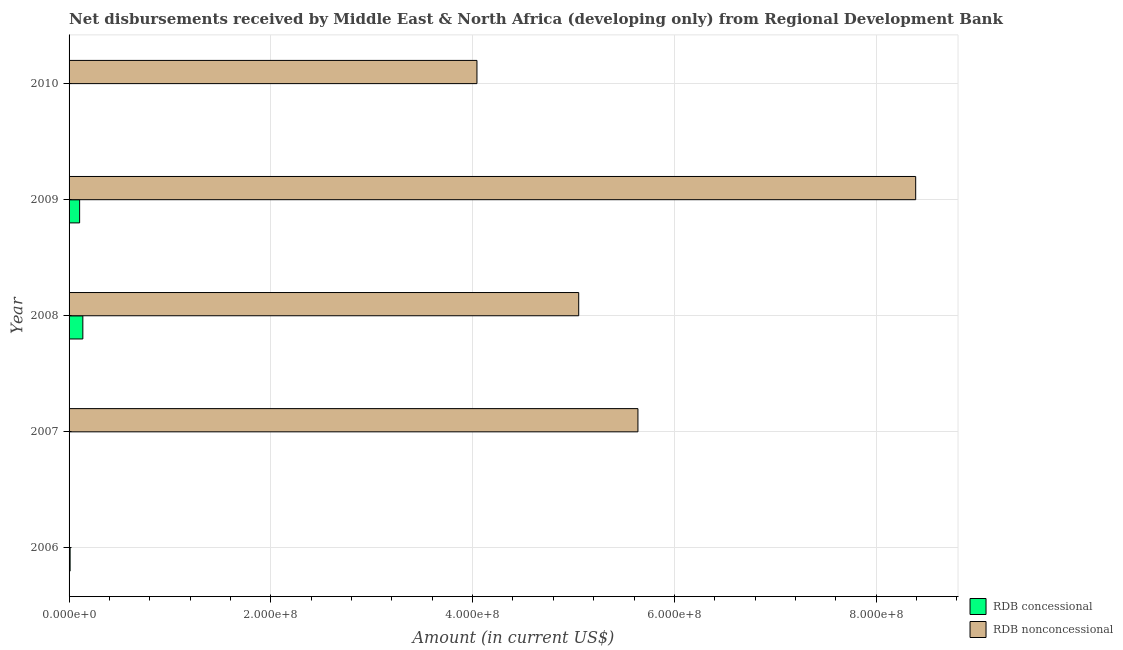Are the number of bars per tick equal to the number of legend labels?
Your answer should be very brief. No. Are the number of bars on each tick of the Y-axis equal?
Keep it short and to the point. No. How many bars are there on the 1st tick from the top?
Keep it short and to the point. 1. How many bars are there on the 1st tick from the bottom?
Ensure brevity in your answer.  1. What is the net non concessional disbursements from rdb in 2006?
Provide a succinct answer. 0. Across all years, what is the maximum net non concessional disbursements from rdb?
Provide a succinct answer. 8.39e+08. What is the total net concessional disbursements from rdb in the graph?
Keep it short and to the point. 2.54e+07. What is the difference between the net non concessional disbursements from rdb in 2008 and that in 2009?
Offer a terse response. -3.34e+08. What is the difference between the net non concessional disbursements from rdb in 2007 and the net concessional disbursements from rdb in 2010?
Provide a succinct answer. 5.64e+08. What is the average net concessional disbursements from rdb per year?
Provide a short and direct response. 5.08e+06. In the year 2008, what is the difference between the net concessional disbursements from rdb and net non concessional disbursements from rdb?
Your response must be concise. -4.92e+08. In how many years, is the net concessional disbursements from rdb greater than 760000000 US$?
Keep it short and to the point. 0. What is the ratio of the net concessional disbursements from rdb in 2008 to that in 2009?
Provide a succinct answer. 1.3. Is the net concessional disbursements from rdb in 2007 less than that in 2009?
Keep it short and to the point. Yes. Is the difference between the net non concessional disbursements from rdb in 2008 and 2009 greater than the difference between the net concessional disbursements from rdb in 2008 and 2009?
Your answer should be very brief. No. What is the difference between the highest and the second highest net non concessional disbursements from rdb?
Keep it short and to the point. 2.75e+08. What is the difference between the highest and the lowest net concessional disbursements from rdb?
Your answer should be very brief. 1.36e+07. In how many years, is the net non concessional disbursements from rdb greater than the average net non concessional disbursements from rdb taken over all years?
Provide a short and direct response. 3. Is the sum of the net non concessional disbursements from rdb in 2008 and 2009 greater than the maximum net concessional disbursements from rdb across all years?
Give a very brief answer. Yes. How many bars are there?
Provide a succinct answer. 8. Are the values on the major ticks of X-axis written in scientific E-notation?
Give a very brief answer. Yes. Does the graph contain any zero values?
Offer a terse response. Yes. Does the graph contain grids?
Ensure brevity in your answer.  Yes. How many legend labels are there?
Keep it short and to the point. 2. What is the title of the graph?
Your answer should be very brief. Net disbursements received by Middle East & North Africa (developing only) from Regional Development Bank. What is the label or title of the X-axis?
Provide a short and direct response. Amount (in current US$). What is the label or title of the Y-axis?
Keep it short and to the point. Year. What is the Amount (in current US$) in RDB concessional in 2006?
Your answer should be compact. 1.03e+06. What is the Amount (in current US$) in RDB concessional in 2007?
Provide a succinct answer. 2.37e+05. What is the Amount (in current US$) in RDB nonconcessional in 2007?
Your answer should be compact. 5.64e+08. What is the Amount (in current US$) of RDB concessional in 2008?
Provide a succinct answer. 1.36e+07. What is the Amount (in current US$) of RDB nonconcessional in 2008?
Provide a short and direct response. 5.05e+08. What is the Amount (in current US$) of RDB concessional in 2009?
Provide a succinct answer. 1.05e+07. What is the Amount (in current US$) in RDB nonconcessional in 2009?
Offer a terse response. 8.39e+08. What is the Amount (in current US$) in RDB concessional in 2010?
Make the answer very short. 0. What is the Amount (in current US$) in RDB nonconcessional in 2010?
Your answer should be very brief. 4.04e+08. Across all years, what is the maximum Amount (in current US$) in RDB concessional?
Your response must be concise. 1.36e+07. Across all years, what is the maximum Amount (in current US$) in RDB nonconcessional?
Give a very brief answer. 8.39e+08. What is the total Amount (in current US$) in RDB concessional in the graph?
Your response must be concise. 2.54e+07. What is the total Amount (in current US$) in RDB nonconcessional in the graph?
Your answer should be very brief. 2.31e+09. What is the difference between the Amount (in current US$) in RDB concessional in 2006 and that in 2007?
Your answer should be very brief. 7.89e+05. What is the difference between the Amount (in current US$) in RDB concessional in 2006 and that in 2008?
Your answer should be compact. -1.26e+07. What is the difference between the Amount (in current US$) of RDB concessional in 2006 and that in 2009?
Ensure brevity in your answer.  -9.44e+06. What is the difference between the Amount (in current US$) of RDB concessional in 2007 and that in 2008?
Provide a short and direct response. -1.34e+07. What is the difference between the Amount (in current US$) in RDB nonconcessional in 2007 and that in 2008?
Offer a terse response. 5.87e+07. What is the difference between the Amount (in current US$) in RDB concessional in 2007 and that in 2009?
Provide a succinct answer. -1.02e+07. What is the difference between the Amount (in current US$) of RDB nonconcessional in 2007 and that in 2009?
Provide a short and direct response. -2.75e+08. What is the difference between the Amount (in current US$) of RDB nonconcessional in 2007 and that in 2010?
Give a very brief answer. 1.60e+08. What is the difference between the Amount (in current US$) of RDB concessional in 2008 and that in 2009?
Make the answer very short. 3.19e+06. What is the difference between the Amount (in current US$) of RDB nonconcessional in 2008 and that in 2009?
Make the answer very short. -3.34e+08. What is the difference between the Amount (in current US$) of RDB nonconcessional in 2008 and that in 2010?
Keep it short and to the point. 1.01e+08. What is the difference between the Amount (in current US$) in RDB nonconcessional in 2009 and that in 2010?
Provide a short and direct response. 4.35e+08. What is the difference between the Amount (in current US$) of RDB concessional in 2006 and the Amount (in current US$) of RDB nonconcessional in 2007?
Your answer should be very brief. -5.63e+08. What is the difference between the Amount (in current US$) of RDB concessional in 2006 and the Amount (in current US$) of RDB nonconcessional in 2008?
Give a very brief answer. -5.04e+08. What is the difference between the Amount (in current US$) of RDB concessional in 2006 and the Amount (in current US$) of RDB nonconcessional in 2009?
Ensure brevity in your answer.  -8.38e+08. What is the difference between the Amount (in current US$) in RDB concessional in 2006 and the Amount (in current US$) in RDB nonconcessional in 2010?
Offer a terse response. -4.03e+08. What is the difference between the Amount (in current US$) in RDB concessional in 2007 and the Amount (in current US$) in RDB nonconcessional in 2008?
Your answer should be very brief. -5.05e+08. What is the difference between the Amount (in current US$) in RDB concessional in 2007 and the Amount (in current US$) in RDB nonconcessional in 2009?
Offer a terse response. -8.39e+08. What is the difference between the Amount (in current US$) in RDB concessional in 2007 and the Amount (in current US$) in RDB nonconcessional in 2010?
Offer a very short reply. -4.04e+08. What is the difference between the Amount (in current US$) in RDB concessional in 2008 and the Amount (in current US$) in RDB nonconcessional in 2009?
Your answer should be very brief. -8.26e+08. What is the difference between the Amount (in current US$) in RDB concessional in 2008 and the Amount (in current US$) in RDB nonconcessional in 2010?
Your response must be concise. -3.91e+08. What is the difference between the Amount (in current US$) of RDB concessional in 2009 and the Amount (in current US$) of RDB nonconcessional in 2010?
Your answer should be compact. -3.94e+08. What is the average Amount (in current US$) of RDB concessional per year?
Ensure brevity in your answer.  5.08e+06. What is the average Amount (in current US$) in RDB nonconcessional per year?
Keep it short and to the point. 4.63e+08. In the year 2007, what is the difference between the Amount (in current US$) of RDB concessional and Amount (in current US$) of RDB nonconcessional?
Your answer should be very brief. -5.64e+08. In the year 2008, what is the difference between the Amount (in current US$) of RDB concessional and Amount (in current US$) of RDB nonconcessional?
Make the answer very short. -4.92e+08. In the year 2009, what is the difference between the Amount (in current US$) in RDB concessional and Amount (in current US$) in RDB nonconcessional?
Offer a very short reply. -8.29e+08. What is the ratio of the Amount (in current US$) in RDB concessional in 2006 to that in 2007?
Offer a very short reply. 4.33. What is the ratio of the Amount (in current US$) of RDB concessional in 2006 to that in 2008?
Give a very brief answer. 0.08. What is the ratio of the Amount (in current US$) in RDB concessional in 2006 to that in 2009?
Offer a very short reply. 0.1. What is the ratio of the Amount (in current US$) in RDB concessional in 2007 to that in 2008?
Offer a very short reply. 0.02. What is the ratio of the Amount (in current US$) in RDB nonconcessional in 2007 to that in 2008?
Your answer should be compact. 1.12. What is the ratio of the Amount (in current US$) in RDB concessional in 2007 to that in 2009?
Offer a very short reply. 0.02. What is the ratio of the Amount (in current US$) of RDB nonconcessional in 2007 to that in 2009?
Give a very brief answer. 0.67. What is the ratio of the Amount (in current US$) of RDB nonconcessional in 2007 to that in 2010?
Offer a very short reply. 1.39. What is the ratio of the Amount (in current US$) of RDB concessional in 2008 to that in 2009?
Provide a short and direct response. 1.3. What is the ratio of the Amount (in current US$) of RDB nonconcessional in 2008 to that in 2009?
Give a very brief answer. 0.6. What is the ratio of the Amount (in current US$) in RDB nonconcessional in 2008 to that in 2010?
Provide a succinct answer. 1.25. What is the ratio of the Amount (in current US$) in RDB nonconcessional in 2009 to that in 2010?
Your answer should be compact. 2.08. What is the difference between the highest and the second highest Amount (in current US$) in RDB concessional?
Your answer should be compact. 3.19e+06. What is the difference between the highest and the second highest Amount (in current US$) in RDB nonconcessional?
Offer a very short reply. 2.75e+08. What is the difference between the highest and the lowest Amount (in current US$) of RDB concessional?
Your response must be concise. 1.36e+07. What is the difference between the highest and the lowest Amount (in current US$) in RDB nonconcessional?
Your answer should be compact. 8.39e+08. 